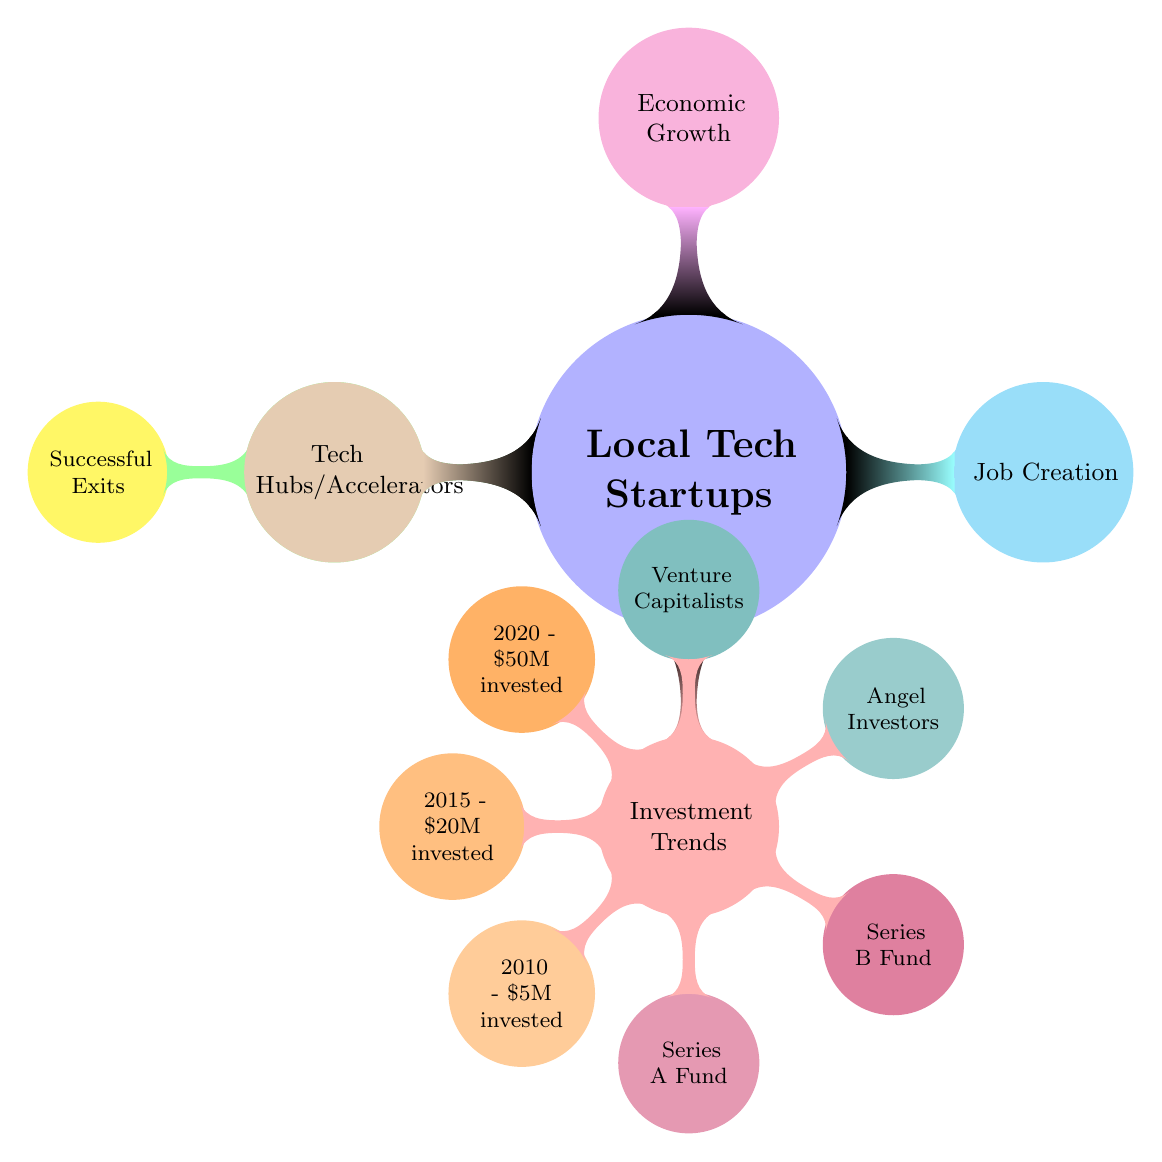What is the total amount invested in startups by 2020? The diagram specifies that in 2020, the investment in local tech startups was \$50M. This is taken directly from the relevant node under the Investment Trends section.
Answer: \$50M What was the investment amount in 2015? According to the diagram, the investment amount for the year 2015 is indicated as \$20M. This information is retrieved from the Investment Trends section, specifically the node related to 2015.
Answer: \$20M How many types of investors are mentioned? The diagram lists four types of investors: Angel Investors, Venture Capitalists, Series A Fund, and Series B Fund. By counting the nodes under Investment Trends, we find that there are four distinct categories of investors.
Answer: 4 What is the primary factor contributing to economic growth? The diagram presents "Economic Growth" as one of the main areas affected by local tech startups. Since it doesn't indicate a singular factor within the node, we can interpret that local tech startups contribute primarily to economic growth as shown directly by this node.
Answer: Local Tech Startups Which year saw the least investment in tech startups? The investment record begins from 2010 with \$5M, which is the lowest among the mentioned years (2010, 2015, and 2020). Therefore, regarding investment trends, 2010 reflects the least investment in tech startups.
Answer: 2010 What are the two categories under "Growth Over Decade"? The diagram presents "Growth Over Decade" with one clear subcategory listed as "Successful Exits." This categorizes the area and implies that it focuses on these growth aspects within the decade.
Answer: Successful Exits How many categories are in the main section of local tech startups? The main section under "Local Tech Startups" consists of five branches: Growth Over Decade, Investment Trends, Job Creation, Economic Growth, and Tech Hubs/Accelerators. Therefore, counting these nodes gives us the total number of categories.
Answer: 5 What is the color of the "Investment Trends" node? The "Investment Trends" node is highlighted in red, which is a definitive visual characteristic of that aspect of the diagram.
Answer: Red What is the significance of successful exits in the context of the diagram? Successful exits are mentioned under "Growth Over Decade," indicating an essential aspect of growth in local tech startups, suggesting that successful exits are vital as a measure for growth and success in the startup ecosystem.
Answer: Essential for growth 